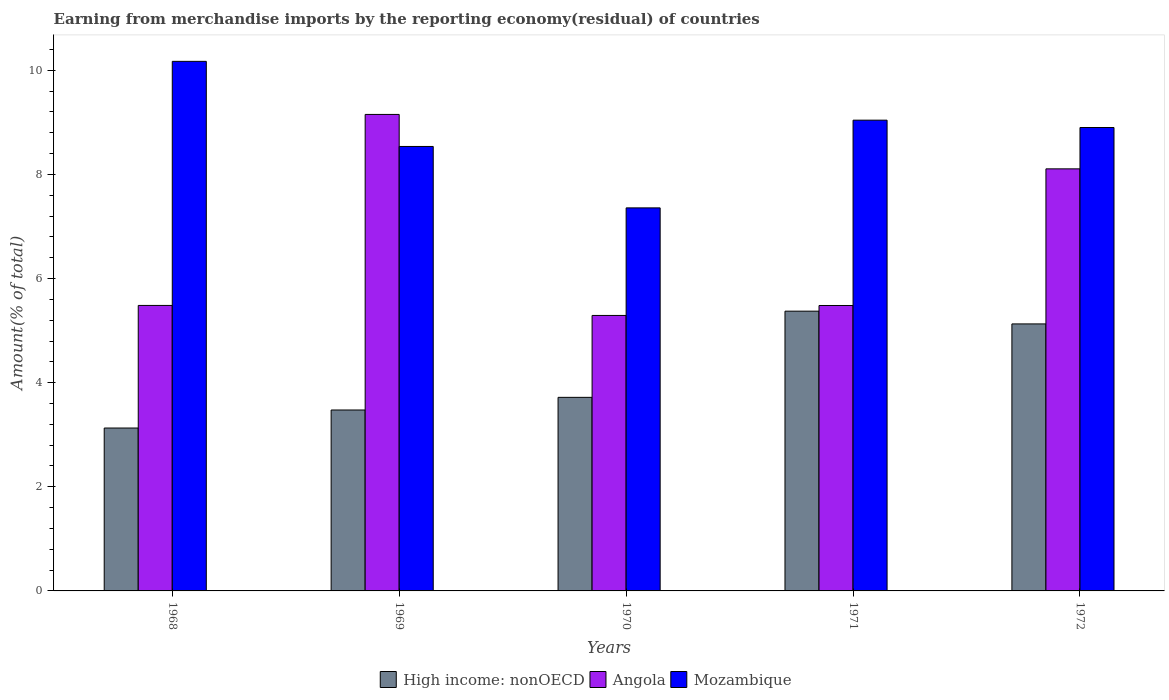How many groups of bars are there?
Offer a very short reply. 5. Are the number of bars on each tick of the X-axis equal?
Ensure brevity in your answer.  Yes. How many bars are there on the 2nd tick from the right?
Your answer should be compact. 3. What is the label of the 1st group of bars from the left?
Give a very brief answer. 1968. In how many cases, is the number of bars for a given year not equal to the number of legend labels?
Ensure brevity in your answer.  0. What is the percentage of amount earned from merchandise imports in High income: nonOECD in 1968?
Keep it short and to the point. 3.13. Across all years, what is the maximum percentage of amount earned from merchandise imports in Mozambique?
Make the answer very short. 10.17. Across all years, what is the minimum percentage of amount earned from merchandise imports in Mozambique?
Provide a succinct answer. 7.36. In which year was the percentage of amount earned from merchandise imports in Mozambique maximum?
Your response must be concise. 1968. In which year was the percentage of amount earned from merchandise imports in Mozambique minimum?
Offer a terse response. 1970. What is the total percentage of amount earned from merchandise imports in Mozambique in the graph?
Your response must be concise. 44.01. What is the difference between the percentage of amount earned from merchandise imports in High income: nonOECD in 1968 and that in 1970?
Offer a terse response. -0.59. What is the difference between the percentage of amount earned from merchandise imports in Angola in 1968 and the percentage of amount earned from merchandise imports in High income: nonOECD in 1969?
Offer a terse response. 2.01. What is the average percentage of amount earned from merchandise imports in Angola per year?
Offer a terse response. 6.7. In the year 1968, what is the difference between the percentage of amount earned from merchandise imports in High income: nonOECD and percentage of amount earned from merchandise imports in Angola?
Provide a succinct answer. -2.35. In how many years, is the percentage of amount earned from merchandise imports in High income: nonOECD greater than 7.6 %?
Provide a succinct answer. 0. What is the ratio of the percentage of amount earned from merchandise imports in High income: nonOECD in 1969 to that in 1971?
Your response must be concise. 0.65. Is the percentage of amount earned from merchandise imports in Angola in 1968 less than that in 1970?
Your answer should be very brief. No. What is the difference between the highest and the second highest percentage of amount earned from merchandise imports in High income: nonOECD?
Your response must be concise. 0.24. What is the difference between the highest and the lowest percentage of amount earned from merchandise imports in Mozambique?
Your answer should be compact. 2.81. What does the 1st bar from the left in 1969 represents?
Provide a succinct answer. High income: nonOECD. What does the 2nd bar from the right in 1969 represents?
Offer a very short reply. Angola. How many bars are there?
Make the answer very short. 15. How many years are there in the graph?
Offer a very short reply. 5. Where does the legend appear in the graph?
Keep it short and to the point. Bottom center. How are the legend labels stacked?
Ensure brevity in your answer.  Horizontal. What is the title of the graph?
Offer a terse response. Earning from merchandise imports by the reporting economy(residual) of countries. What is the label or title of the X-axis?
Your answer should be very brief. Years. What is the label or title of the Y-axis?
Your answer should be compact. Amount(% of total). What is the Amount(% of total) in High income: nonOECD in 1968?
Offer a terse response. 3.13. What is the Amount(% of total) of Angola in 1968?
Your response must be concise. 5.48. What is the Amount(% of total) of Mozambique in 1968?
Keep it short and to the point. 10.17. What is the Amount(% of total) of High income: nonOECD in 1969?
Ensure brevity in your answer.  3.48. What is the Amount(% of total) of Angola in 1969?
Provide a short and direct response. 9.15. What is the Amount(% of total) of Mozambique in 1969?
Make the answer very short. 8.54. What is the Amount(% of total) of High income: nonOECD in 1970?
Ensure brevity in your answer.  3.72. What is the Amount(% of total) in Angola in 1970?
Offer a terse response. 5.29. What is the Amount(% of total) in Mozambique in 1970?
Provide a succinct answer. 7.36. What is the Amount(% of total) of High income: nonOECD in 1971?
Provide a succinct answer. 5.37. What is the Amount(% of total) of Angola in 1971?
Your response must be concise. 5.48. What is the Amount(% of total) in Mozambique in 1971?
Offer a very short reply. 9.04. What is the Amount(% of total) in High income: nonOECD in 1972?
Your answer should be compact. 5.13. What is the Amount(% of total) in Angola in 1972?
Offer a terse response. 8.11. What is the Amount(% of total) of Mozambique in 1972?
Offer a terse response. 8.9. Across all years, what is the maximum Amount(% of total) of High income: nonOECD?
Offer a very short reply. 5.37. Across all years, what is the maximum Amount(% of total) of Angola?
Provide a short and direct response. 9.15. Across all years, what is the maximum Amount(% of total) in Mozambique?
Keep it short and to the point. 10.17. Across all years, what is the minimum Amount(% of total) in High income: nonOECD?
Offer a terse response. 3.13. Across all years, what is the minimum Amount(% of total) of Angola?
Give a very brief answer. 5.29. Across all years, what is the minimum Amount(% of total) in Mozambique?
Provide a succinct answer. 7.36. What is the total Amount(% of total) of High income: nonOECD in the graph?
Provide a succinct answer. 20.82. What is the total Amount(% of total) in Angola in the graph?
Offer a terse response. 33.52. What is the total Amount(% of total) of Mozambique in the graph?
Make the answer very short. 44.01. What is the difference between the Amount(% of total) of High income: nonOECD in 1968 and that in 1969?
Provide a short and direct response. -0.35. What is the difference between the Amount(% of total) in Angola in 1968 and that in 1969?
Offer a very short reply. -3.67. What is the difference between the Amount(% of total) in Mozambique in 1968 and that in 1969?
Ensure brevity in your answer.  1.63. What is the difference between the Amount(% of total) of High income: nonOECD in 1968 and that in 1970?
Offer a terse response. -0.59. What is the difference between the Amount(% of total) in Angola in 1968 and that in 1970?
Provide a succinct answer. 0.19. What is the difference between the Amount(% of total) in Mozambique in 1968 and that in 1970?
Make the answer very short. 2.81. What is the difference between the Amount(% of total) in High income: nonOECD in 1968 and that in 1971?
Your response must be concise. -2.24. What is the difference between the Amount(% of total) in Angola in 1968 and that in 1971?
Provide a succinct answer. 0. What is the difference between the Amount(% of total) in Mozambique in 1968 and that in 1971?
Your response must be concise. 1.13. What is the difference between the Amount(% of total) in High income: nonOECD in 1968 and that in 1972?
Offer a very short reply. -2. What is the difference between the Amount(% of total) of Angola in 1968 and that in 1972?
Provide a succinct answer. -2.62. What is the difference between the Amount(% of total) of Mozambique in 1968 and that in 1972?
Make the answer very short. 1.27. What is the difference between the Amount(% of total) in High income: nonOECD in 1969 and that in 1970?
Your answer should be compact. -0.24. What is the difference between the Amount(% of total) in Angola in 1969 and that in 1970?
Ensure brevity in your answer.  3.86. What is the difference between the Amount(% of total) of Mozambique in 1969 and that in 1970?
Your answer should be very brief. 1.18. What is the difference between the Amount(% of total) of High income: nonOECD in 1969 and that in 1971?
Provide a succinct answer. -1.9. What is the difference between the Amount(% of total) of Angola in 1969 and that in 1971?
Offer a terse response. 3.67. What is the difference between the Amount(% of total) in Mozambique in 1969 and that in 1971?
Provide a short and direct response. -0.51. What is the difference between the Amount(% of total) in High income: nonOECD in 1969 and that in 1972?
Give a very brief answer. -1.65. What is the difference between the Amount(% of total) in Angola in 1969 and that in 1972?
Offer a terse response. 1.05. What is the difference between the Amount(% of total) of Mozambique in 1969 and that in 1972?
Provide a succinct answer. -0.36. What is the difference between the Amount(% of total) in High income: nonOECD in 1970 and that in 1971?
Your answer should be compact. -1.66. What is the difference between the Amount(% of total) of Angola in 1970 and that in 1971?
Make the answer very short. -0.19. What is the difference between the Amount(% of total) in Mozambique in 1970 and that in 1971?
Give a very brief answer. -1.68. What is the difference between the Amount(% of total) of High income: nonOECD in 1970 and that in 1972?
Keep it short and to the point. -1.41. What is the difference between the Amount(% of total) in Angola in 1970 and that in 1972?
Ensure brevity in your answer.  -2.82. What is the difference between the Amount(% of total) in Mozambique in 1970 and that in 1972?
Offer a very short reply. -1.54. What is the difference between the Amount(% of total) of High income: nonOECD in 1971 and that in 1972?
Make the answer very short. 0.24. What is the difference between the Amount(% of total) in Angola in 1971 and that in 1972?
Your answer should be very brief. -2.62. What is the difference between the Amount(% of total) in Mozambique in 1971 and that in 1972?
Your response must be concise. 0.14. What is the difference between the Amount(% of total) in High income: nonOECD in 1968 and the Amount(% of total) in Angola in 1969?
Provide a short and direct response. -6.02. What is the difference between the Amount(% of total) of High income: nonOECD in 1968 and the Amount(% of total) of Mozambique in 1969?
Your answer should be very brief. -5.41. What is the difference between the Amount(% of total) of Angola in 1968 and the Amount(% of total) of Mozambique in 1969?
Offer a very short reply. -3.05. What is the difference between the Amount(% of total) of High income: nonOECD in 1968 and the Amount(% of total) of Angola in 1970?
Your answer should be very brief. -2.16. What is the difference between the Amount(% of total) in High income: nonOECD in 1968 and the Amount(% of total) in Mozambique in 1970?
Your answer should be compact. -4.23. What is the difference between the Amount(% of total) in Angola in 1968 and the Amount(% of total) in Mozambique in 1970?
Your answer should be compact. -1.87. What is the difference between the Amount(% of total) of High income: nonOECD in 1968 and the Amount(% of total) of Angola in 1971?
Offer a terse response. -2.35. What is the difference between the Amount(% of total) in High income: nonOECD in 1968 and the Amount(% of total) in Mozambique in 1971?
Offer a very short reply. -5.91. What is the difference between the Amount(% of total) in Angola in 1968 and the Amount(% of total) in Mozambique in 1971?
Offer a terse response. -3.56. What is the difference between the Amount(% of total) of High income: nonOECD in 1968 and the Amount(% of total) of Angola in 1972?
Your answer should be compact. -4.98. What is the difference between the Amount(% of total) in High income: nonOECD in 1968 and the Amount(% of total) in Mozambique in 1972?
Your answer should be compact. -5.77. What is the difference between the Amount(% of total) of Angola in 1968 and the Amount(% of total) of Mozambique in 1972?
Your answer should be very brief. -3.42. What is the difference between the Amount(% of total) of High income: nonOECD in 1969 and the Amount(% of total) of Angola in 1970?
Your answer should be compact. -1.82. What is the difference between the Amount(% of total) in High income: nonOECD in 1969 and the Amount(% of total) in Mozambique in 1970?
Provide a succinct answer. -3.88. What is the difference between the Amount(% of total) in Angola in 1969 and the Amount(% of total) in Mozambique in 1970?
Provide a succinct answer. 1.79. What is the difference between the Amount(% of total) in High income: nonOECD in 1969 and the Amount(% of total) in Angola in 1971?
Ensure brevity in your answer.  -2.01. What is the difference between the Amount(% of total) in High income: nonOECD in 1969 and the Amount(% of total) in Mozambique in 1971?
Keep it short and to the point. -5.57. What is the difference between the Amount(% of total) of Angola in 1969 and the Amount(% of total) of Mozambique in 1971?
Offer a terse response. 0.11. What is the difference between the Amount(% of total) in High income: nonOECD in 1969 and the Amount(% of total) in Angola in 1972?
Offer a terse response. -4.63. What is the difference between the Amount(% of total) in High income: nonOECD in 1969 and the Amount(% of total) in Mozambique in 1972?
Offer a very short reply. -5.43. What is the difference between the Amount(% of total) in Angola in 1969 and the Amount(% of total) in Mozambique in 1972?
Give a very brief answer. 0.25. What is the difference between the Amount(% of total) in High income: nonOECD in 1970 and the Amount(% of total) in Angola in 1971?
Provide a succinct answer. -1.76. What is the difference between the Amount(% of total) of High income: nonOECD in 1970 and the Amount(% of total) of Mozambique in 1971?
Provide a succinct answer. -5.32. What is the difference between the Amount(% of total) in Angola in 1970 and the Amount(% of total) in Mozambique in 1971?
Provide a succinct answer. -3.75. What is the difference between the Amount(% of total) of High income: nonOECD in 1970 and the Amount(% of total) of Angola in 1972?
Offer a very short reply. -4.39. What is the difference between the Amount(% of total) of High income: nonOECD in 1970 and the Amount(% of total) of Mozambique in 1972?
Your answer should be compact. -5.18. What is the difference between the Amount(% of total) of Angola in 1970 and the Amount(% of total) of Mozambique in 1972?
Your response must be concise. -3.61. What is the difference between the Amount(% of total) of High income: nonOECD in 1971 and the Amount(% of total) of Angola in 1972?
Your response must be concise. -2.73. What is the difference between the Amount(% of total) in High income: nonOECD in 1971 and the Amount(% of total) in Mozambique in 1972?
Your answer should be very brief. -3.53. What is the difference between the Amount(% of total) of Angola in 1971 and the Amount(% of total) of Mozambique in 1972?
Provide a succinct answer. -3.42. What is the average Amount(% of total) of High income: nonOECD per year?
Give a very brief answer. 4.16. What is the average Amount(% of total) of Angola per year?
Offer a very short reply. 6.7. What is the average Amount(% of total) of Mozambique per year?
Offer a terse response. 8.8. In the year 1968, what is the difference between the Amount(% of total) of High income: nonOECD and Amount(% of total) of Angola?
Offer a very short reply. -2.35. In the year 1968, what is the difference between the Amount(% of total) in High income: nonOECD and Amount(% of total) in Mozambique?
Offer a terse response. -7.04. In the year 1968, what is the difference between the Amount(% of total) of Angola and Amount(% of total) of Mozambique?
Offer a terse response. -4.69. In the year 1969, what is the difference between the Amount(% of total) in High income: nonOECD and Amount(% of total) in Angola?
Offer a terse response. -5.68. In the year 1969, what is the difference between the Amount(% of total) in High income: nonOECD and Amount(% of total) in Mozambique?
Your response must be concise. -5.06. In the year 1969, what is the difference between the Amount(% of total) in Angola and Amount(% of total) in Mozambique?
Give a very brief answer. 0.62. In the year 1970, what is the difference between the Amount(% of total) in High income: nonOECD and Amount(% of total) in Angola?
Ensure brevity in your answer.  -1.57. In the year 1970, what is the difference between the Amount(% of total) of High income: nonOECD and Amount(% of total) of Mozambique?
Your response must be concise. -3.64. In the year 1970, what is the difference between the Amount(% of total) of Angola and Amount(% of total) of Mozambique?
Keep it short and to the point. -2.07. In the year 1971, what is the difference between the Amount(% of total) of High income: nonOECD and Amount(% of total) of Angola?
Provide a succinct answer. -0.11. In the year 1971, what is the difference between the Amount(% of total) in High income: nonOECD and Amount(% of total) in Mozambique?
Your answer should be compact. -3.67. In the year 1971, what is the difference between the Amount(% of total) in Angola and Amount(% of total) in Mozambique?
Offer a terse response. -3.56. In the year 1972, what is the difference between the Amount(% of total) in High income: nonOECD and Amount(% of total) in Angola?
Ensure brevity in your answer.  -2.98. In the year 1972, what is the difference between the Amount(% of total) of High income: nonOECD and Amount(% of total) of Mozambique?
Provide a short and direct response. -3.77. In the year 1972, what is the difference between the Amount(% of total) of Angola and Amount(% of total) of Mozambique?
Your answer should be compact. -0.79. What is the ratio of the Amount(% of total) in High income: nonOECD in 1968 to that in 1969?
Provide a short and direct response. 0.9. What is the ratio of the Amount(% of total) in Angola in 1968 to that in 1969?
Provide a short and direct response. 0.6. What is the ratio of the Amount(% of total) of Mozambique in 1968 to that in 1969?
Give a very brief answer. 1.19. What is the ratio of the Amount(% of total) of High income: nonOECD in 1968 to that in 1970?
Offer a very short reply. 0.84. What is the ratio of the Amount(% of total) of Angola in 1968 to that in 1970?
Make the answer very short. 1.04. What is the ratio of the Amount(% of total) in Mozambique in 1968 to that in 1970?
Give a very brief answer. 1.38. What is the ratio of the Amount(% of total) of High income: nonOECD in 1968 to that in 1971?
Ensure brevity in your answer.  0.58. What is the ratio of the Amount(% of total) in Angola in 1968 to that in 1971?
Offer a terse response. 1. What is the ratio of the Amount(% of total) in Mozambique in 1968 to that in 1971?
Make the answer very short. 1.12. What is the ratio of the Amount(% of total) of High income: nonOECD in 1968 to that in 1972?
Your response must be concise. 0.61. What is the ratio of the Amount(% of total) in Angola in 1968 to that in 1972?
Your answer should be very brief. 0.68. What is the ratio of the Amount(% of total) in Mozambique in 1968 to that in 1972?
Provide a short and direct response. 1.14. What is the ratio of the Amount(% of total) of High income: nonOECD in 1969 to that in 1970?
Provide a succinct answer. 0.93. What is the ratio of the Amount(% of total) of Angola in 1969 to that in 1970?
Your response must be concise. 1.73. What is the ratio of the Amount(% of total) of Mozambique in 1969 to that in 1970?
Your response must be concise. 1.16. What is the ratio of the Amount(% of total) in High income: nonOECD in 1969 to that in 1971?
Your answer should be very brief. 0.65. What is the ratio of the Amount(% of total) in Angola in 1969 to that in 1971?
Offer a very short reply. 1.67. What is the ratio of the Amount(% of total) in Mozambique in 1969 to that in 1971?
Your answer should be very brief. 0.94. What is the ratio of the Amount(% of total) of High income: nonOECD in 1969 to that in 1972?
Your response must be concise. 0.68. What is the ratio of the Amount(% of total) in Angola in 1969 to that in 1972?
Offer a terse response. 1.13. What is the ratio of the Amount(% of total) in Mozambique in 1969 to that in 1972?
Offer a terse response. 0.96. What is the ratio of the Amount(% of total) of High income: nonOECD in 1970 to that in 1971?
Provide a succinct answer. 0.69. What is the ratio of the Amount(% of total) of Angola in 1970 to that in 1971?
Give a very brief answer. 0.97. What is the ratio of the Amount(% of total) in Mozambique in 1970 to that in 1971?
Keep it short and to the point. 0.81. What is the ratio of the Amount(% of total) in High income: nonOECD in 1970 to that in 1972?
Offer a very short reply. 0.72. What is the ratio of the Amount(% of total) in Angola in 1970 to that in 1972?
Provide a succinct answer. 0.65. What is the ratio of the Amount(% of total) of Mozambique in 1970 to that in 1972?
Ensure brevity in your answer.  0.83. What is the ratio of the Amount(% of total) in High income: nonOECD in 1971 to that in 1972?
Your answer should be very brief. 1.05. What is the ratio of the Amount(% of total) of Angola in 1971 to that in 1972?
Your answer should be compact. 0.68. What is the ratio of the Amount(% of total) in Mozambique in 1971 to that in 1972?
Make the answer very short. 1.02. What is the difference between the highest and the second highest Amount(% of total) in High income: nonOECD?
Your answer should be very brief. 0.24. What is the difference between the highest and the second highest Amount(% of total) in Angola?
Your answer should be very brief. 1.05. What is the difference between the highest and the second highest Amount(% of total) in Mozambique?
Give a very brief answer. 1.13. What is the difference between the highest and the lowest Amount(% of total) of High income: nonOECD?
Provide a succinct answer. 2.24. What is the difference between the highest and the lowest Amount(% of total) of Angola?
Your answer should be compact. 3.86. What is the difference between the highest and the lowest Amount(% of total) of Mozambique?
Offer a terse response. 2.81. 